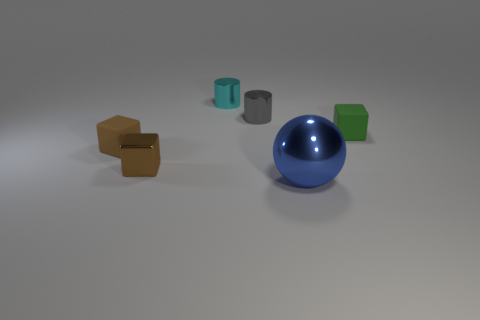Subtract all tiny brown shiny cubes. How many cubes are left? 2 Subtract all blue balls. How many brown blocks are left? 2 Add 1 tiny brown metallic objects. How many objects exist? 7 Subtract all green blocks. How many blocks are left? 2 Subtract all red cubes. Subtract all red cylinders. How many cubes are left? 3 Subtract 0 gray cubes. How many objects are left? 6 Subtract all balls. How many objects are left? 5 Subtract all blue metal things. Subtract all tiny purple rubber spheres. How many objects are left? 5 Add 3 small green cubes. How many small green cubes are left? 4 Add 3 brown blocks. How many brown blocks exist? 5 